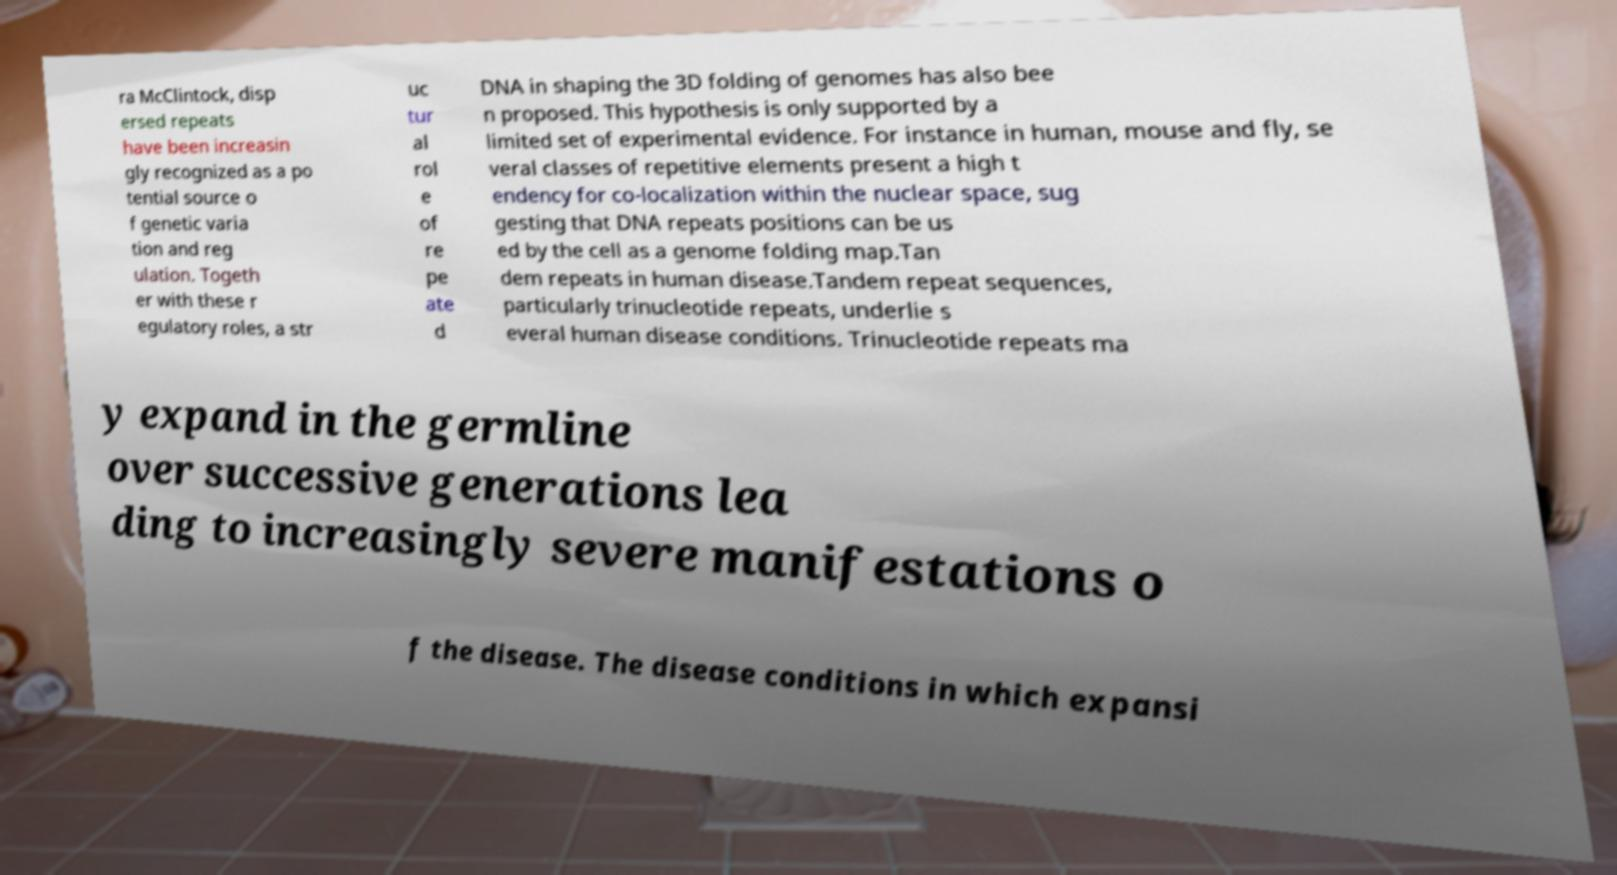For documentation purposes, I need the text within this image transcribed. Could you provide that? ra McClintock, disp ersed repeats have been increasin gly recognized as a po tential source o f genetic varia tion and reg ulation. Togeth er with these r egulatory roles, a str uc tur al rol e of re pe ate d DNA in shaping the 3D folding of genomes has also bee n proposed. This hypothesis is only supported by a limited set of experimental evidence. For instance in human, mouse and fly, se veral classes of repetitive elements present a high t endency for co-localization within the nuclear space, sug gesting that DNA repeats positions can be us ed by the cell as a genome folding map.Tan dem repeats in human disease.Tandem repeat sequences, particularly trinucleotide repeats, underlie s everal human disease conditions. Trinucleotide repeats ma y expand in the germline over successive generations lea ding to increasingly severe manifestations o f the disease. The disease conditions in which expansi 